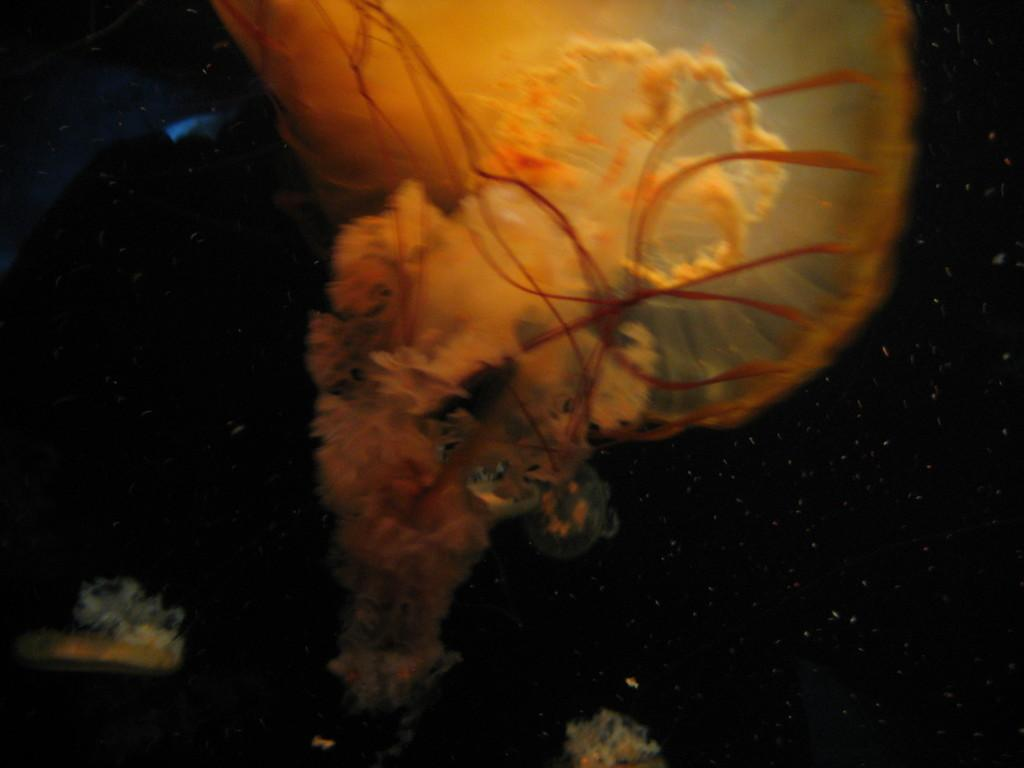What type of animal can be seen in the image? There is a sea creature in the image. Where is the sea creature located? The sea creature is in the water. What color are the jeans worn by the sea creature in the image? There are no jeans present in the image, as sea creatures do not wear clothing. 